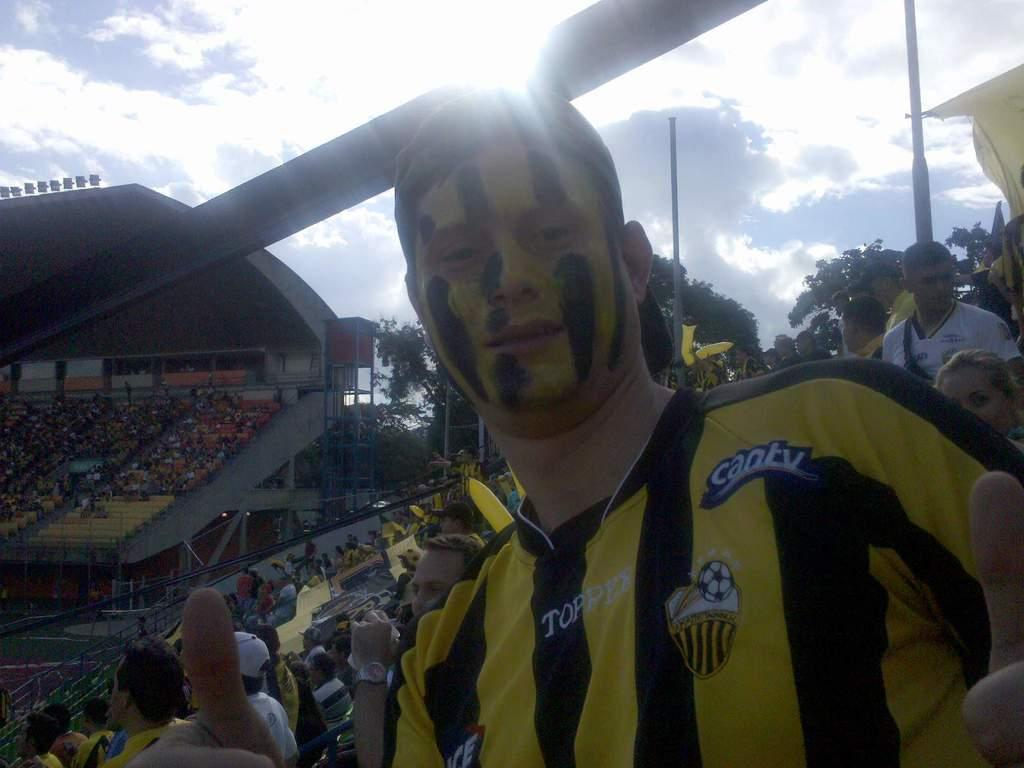<image>
Offer a succinct explanation of the picture presented. a person with can tv written on their shirt and face paint 